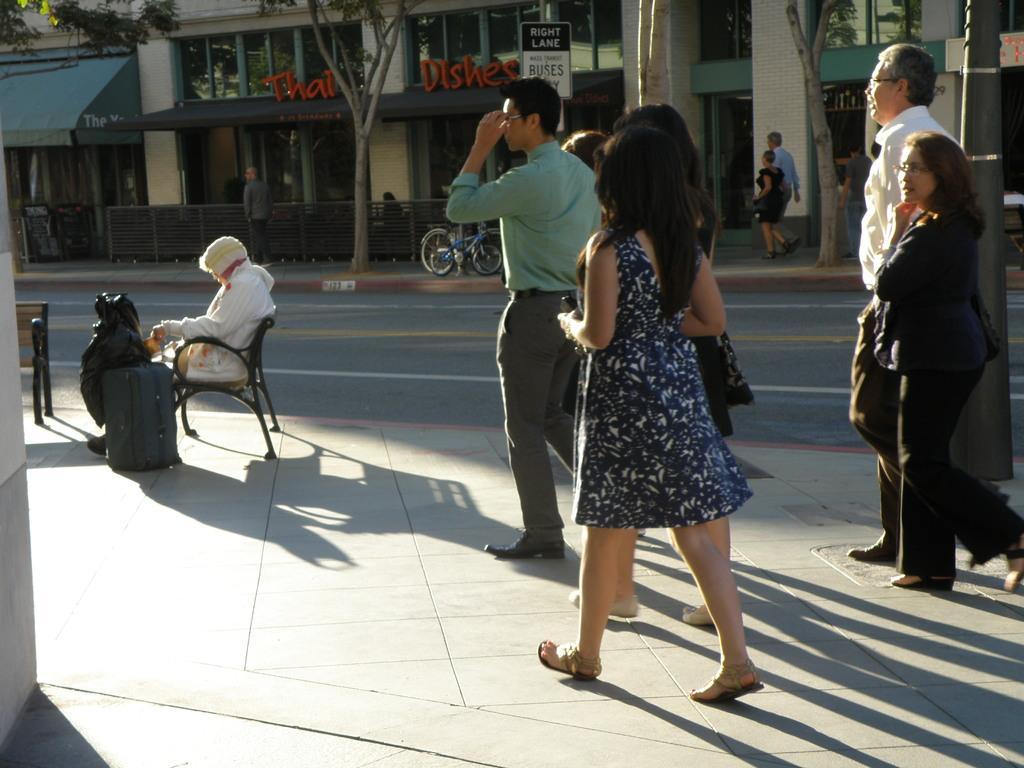Could you give a brief overview of what you see in this image? To the right side of the image there are people walking on the pavement. There is a person sitting on chair. At the background of the image there are buildings,trees. In the center of the image there is road. 